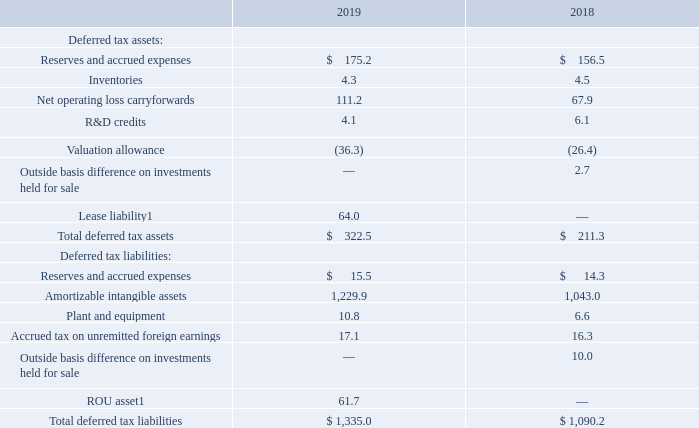The deferred income tax balance sheet accounts arise from temporary differences between the amount of assets and liabilities recognized for financial reporting and tax purposes.
Components of the deferred tax assets and liabilities at December 31 were as follows:
[1] Upon adoption of ASC 842, deferred taxes associated with previously recognized deferred rent liabilities were reclassified into deferred taxes for ROU asset and lease liability.
As of December 31, 2019, the Company had approximately $19.0 of tax-effected U.S. federal net operating loss carryforwards. Some of these net operating loss carryforwards have an indefinite carryforward period, and those that do not will begin to expire in 2021 if not utilized. The majority of the U.S. federal net operating loss carryforwards are subject to limitation under the Internal Revenue Code of 1986, as amended (“IRC”) Section 382; however, the Company expects to utilize such losses in their entirety prior to expiration. The U.S. federal net operating loss carryforwards decreased from 2018 to 2019 primarily due to current year tilization. The Company has approximately $33.7 of tax-effected state net operating loss carryforwards (without regard to federal benefit of state). Some of these net operating loss carryforwards have an indefinite carryforward period, and those that do not will begin to expire in 2020 if not utilized. The state net operating loss carryforwards are primarily related to Florida and New Jersey, but the Company has smaller net operating losses in various other states. The Company has approximately $65.6 of tax-effected foreign net operating loss carryforwards. Some of these net operating loss carryforwards have an indefinite carryforward period, and those that do not will begin to expire in 2020 if not utilized. The foreign net operating loss carryforwards increased from 2018 to 2019 primarily due to the recognition of a discrete tax benefit of $41.0 in connection with a foreign restructuring plan allowing the future realization of net operating losses. Additionally, the Company has $5.0 of U.S. federal and state research and develop- ment tax credit carryforwards (without regard to federal benefit of state). Some of these research and development credit carry- forwards have an indefinite carryforward period, and those that do not will begin to expire in 2020 if not utilized.
As of December 31, 2019, the Company determined that a total valuation allowance of $36.3 was necessary to reduce U.S. fed- eral and state deferred tax assets by $15.4 and foreign deferred tax assets by $20.9, where it was more likely than not that all of such deferred tax assets will not be realized. As of December 31, 2019, the Company believes it is more likely than not that the remaining net deferred tax assets will be realized based on the Company’s estimates of future taxable income and any applicable tax-planning strategies within various tax jurisdictions.
How do the deferred income tax balance sheet accounts arise from? Temporary differences between the amount of assets and liabilities recognized for financial reporting and tax purposes. What are the components of deferred tax assets? Reserves and accrued expenses, inventories, net operating loss carryforwards, r&d credits, valuation allowance, outside basis difference on investments held for sale, lease liability. What was the total deferred tax liabilities in 2018? $ 1,090.2. What is the percentage change in total deferred tax assets from 2018 to 2019?
Answer scale should be: percent. (322.5-211.3)/211.3 
Answer: 52.63. What is the proportion of deferred tax liabilities of amortizable intangible assets as well as the accrued tax on unremitted foreign earnings over total deferred tax liabilities in 2019? (1,229.9+17.1)/1,335.0 
Answer: 0.93. What is the ratio of inventories from 2018 to 2019? 4.5/4.3 
Answer: 1.05. 